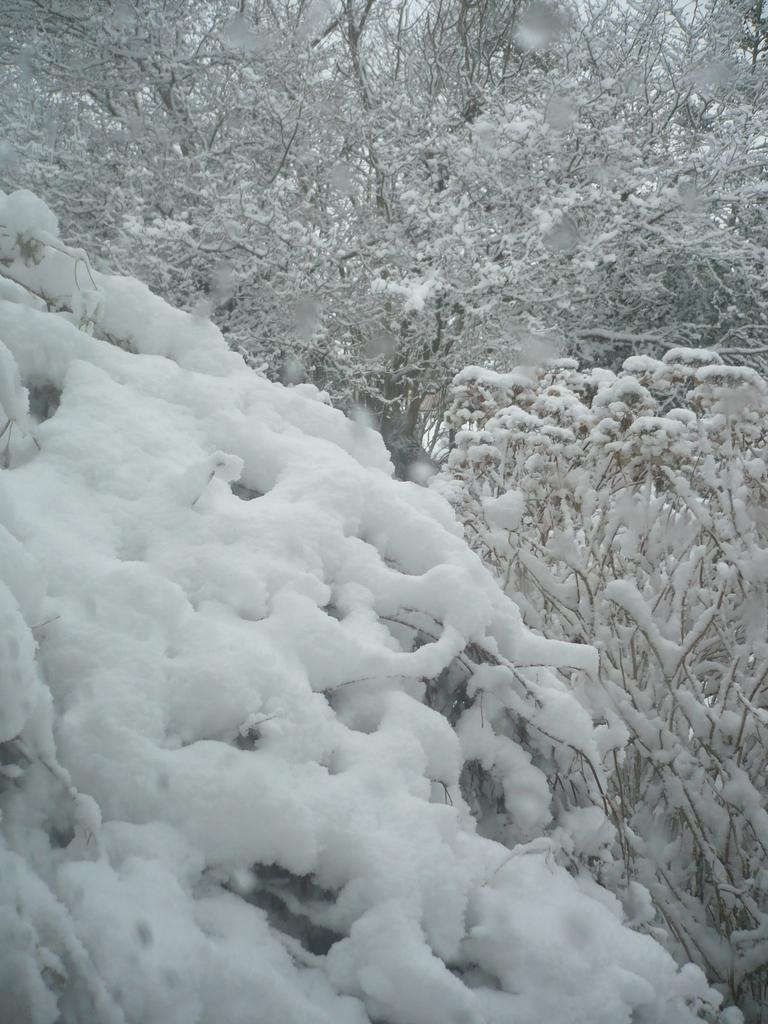What type of vegetation can be seen in the image? There are trees in the image. What is covering the trees in the image? The trees have snow on them. What can be seen in the background of the image? The sky is visible in the background of the image. What type of waste can be seen in the image? There is no waste present in the image; it features trees with snow on them and a visible sky. Is there a box visible in the image? There is no box present in the image. 